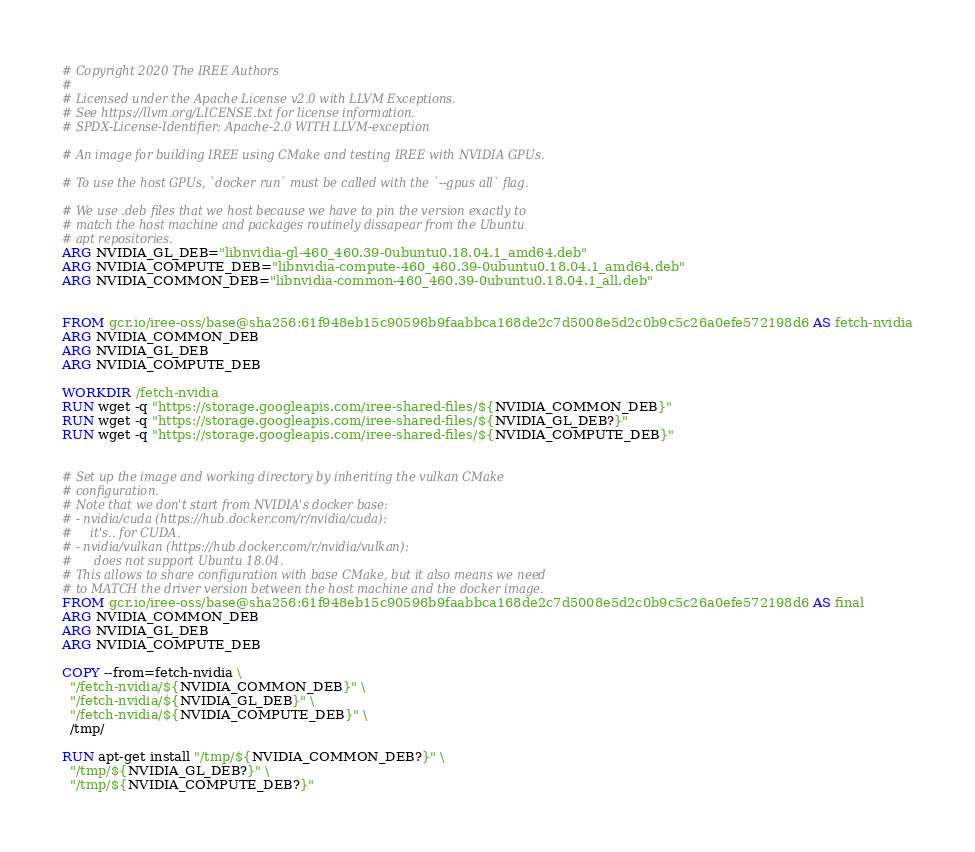<code> <loc_0><loc_0><loc_500><loc_500><_Dockerfile_># Copyright 2020 The IREE Authors
#
# Licensed under the Apache License v2.0 with LLVM Exceptions.
# See https://llvm.org/LICENSE.txt for license information.
# SPDX-License-Identifier: Apache-2.0 WITH LLVM-exception

# An image for building IREE using CMake and testing IREE with NVIDIA GPUs.

# To use the host GPUs, `docker run` must be called with the `--gpus all` flag.

# We use .deb files that we host because we have to pin the version exactly to
# match the host machine and packages routinely dissapear from the Ubuntu
# apt repositories.
ARG NVIDIA_GL_DEB="libnvidia-gl-460_460.39-0ubuntu0.18.04.1_amd64.deb"
ARG NVIDIA_COMPUTE_DEB="libnvidia-compute-460_460.39-0ubuntu0.18.04.1_amd64.deb"
ARG NVIDIA_COMMON_DEB="libnvidia-common-460_460.39-0ubuntu0.18.04.1_all.deb"


FROM gcr.io/iree-oss/base@sha256:61f948eb15c90596b9faabbca168de2c7d5008e5d2c0b9c5c26a0efe572198d6 AS fetch-nvidia
ARG NVIDIA_COMMON_DEB
ARG NVIDIA_GL_DEB
ARG NVIDIA_COMPUTE_DEB

WORKDIR /fetch-nvidia
RUN wget -q "https://storage.googleapis.com/iree-shared-files/${NVIDIA_COMMON_DEB}"
RUN wget -q "https://storage.googleapis.com/iree-shared-files/${NVIDIA_GL_DEB?}"
RUN wget -q "https://storage.googleapis.com/iree-shared-files/${NVIDIA_COMPUTE_DEB}"


# Set up the image and working directory by inheriting the vulkan CMake
# configuration.
# Note that we don't start from NVIDIA's docker base:
# - nvidia/cuda (https://hub.docker.com/r/nvidia/cuda):
#     it's.. for CUDA.
# - nvidia/vulkan (https://hub.docker.com/r/nvidia/vulkan):
#      does not support Ubuntu 18.04.
# This allows to share configuration with base CMake, but it also means we need
# to MATCH the driver version between the host machine and the docker image.
FROM gcr.io/iree-oss/base@sha256:61f948eb15c90596b9faabbca168de2c7d5008e5d2c0b9c5c26a0efe572198d6 AS final
ARG NVIDIA_COMMON_DEB
ARG NVIDIA_GL_DEB
ARG NVIDIA_COMPUTE_DEB

COPY --from=fetch-nvidia \
  "/fetch-nvidia/${NVIDIA_COMMON_DEB}" \
  "/fetch-nvidia/${NVIDIA_GL_DEB}" \
  "/fetch-nvidia/${NVIDIA_COMPUTE_DEB}" \
  /tmp/

RUN apt-get install "/tmp/${NVIDIA_COMMON_DEB?}" \
  "/tmp/${NVIDIA_GL_DEB?}" \
  "/tmp/${NVIDIA_COMPUTE_DEB?}"
</code> 